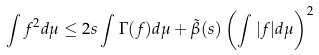<formula> <loc_0><loc_0><loc_500><loc_500>\int f ^ { 2 } d \mu \leq 2 s \int \Gamma ( f ) d \mu + \tilde { \beta } ( s ) \left ( \int | f | d \mu \right ) ^ { 2 }</formula> 